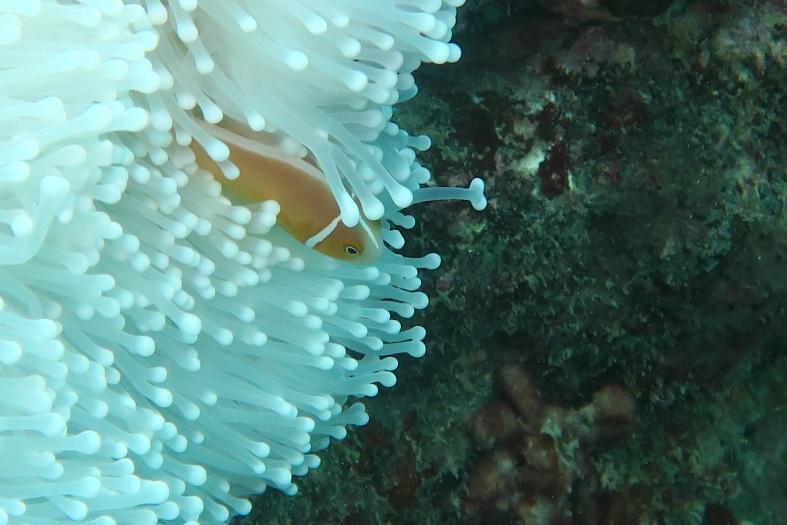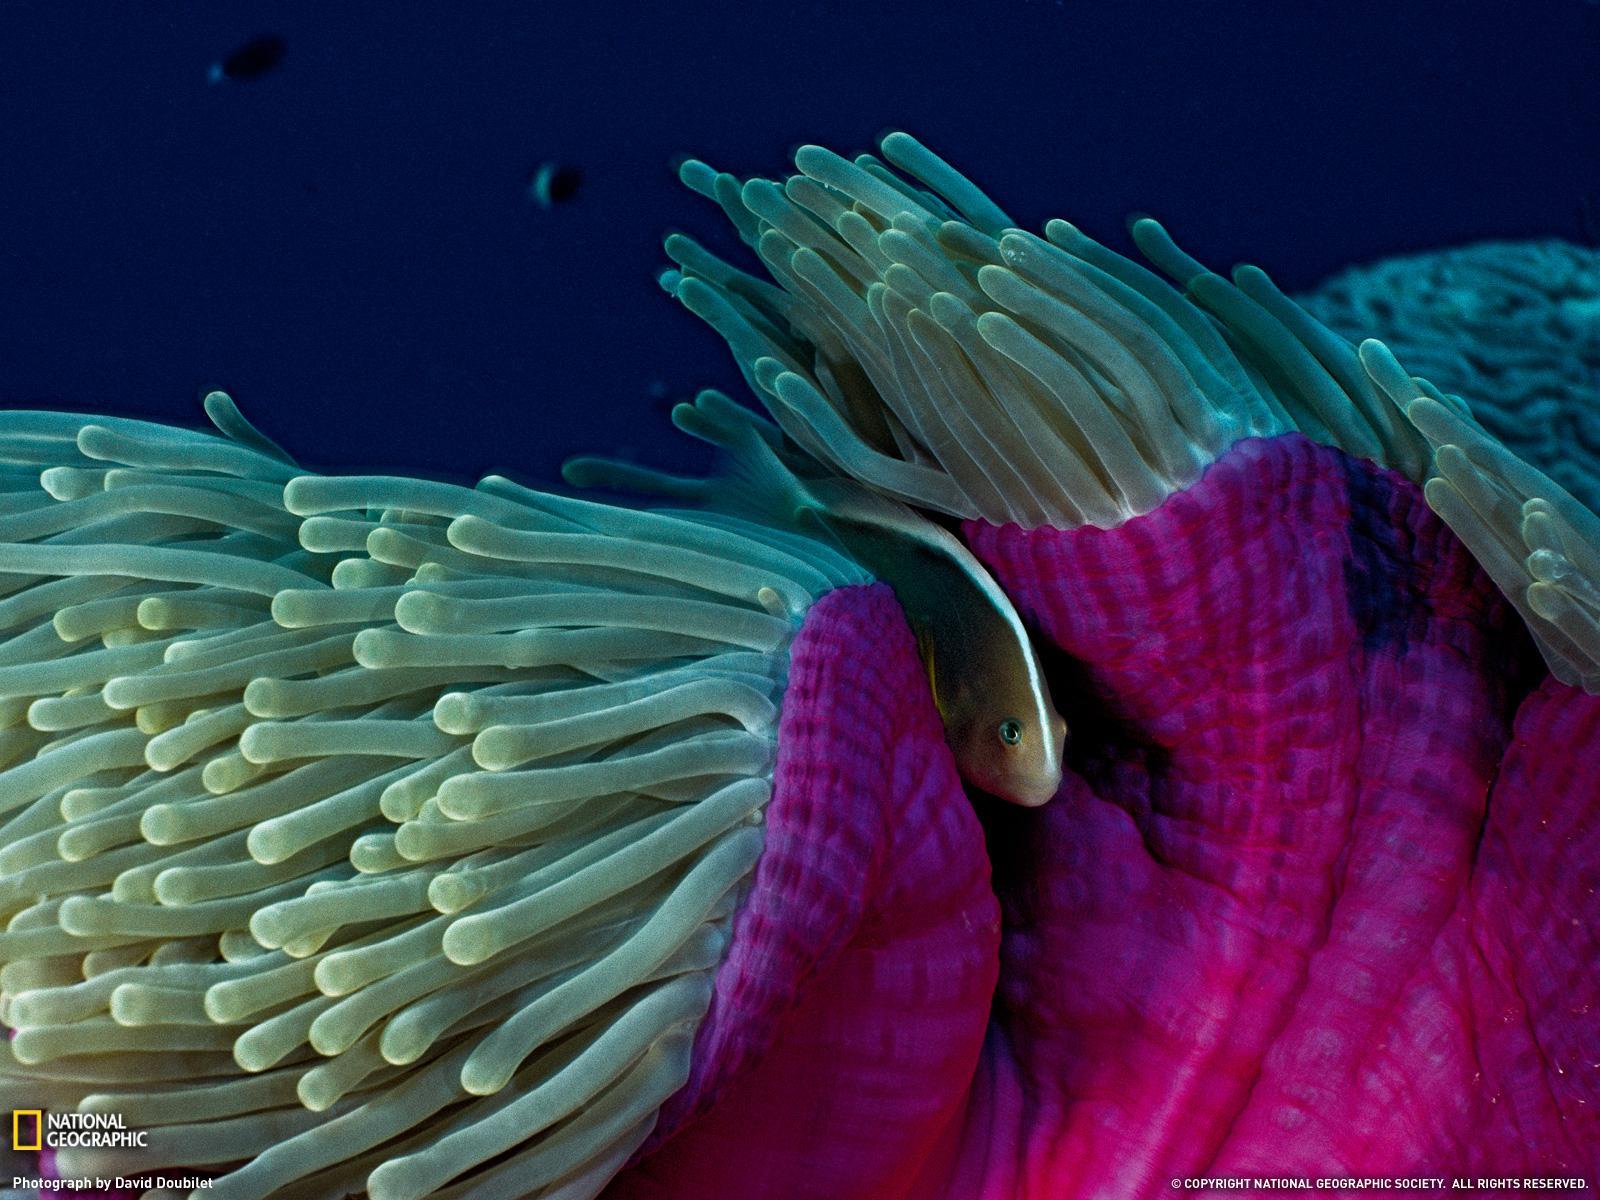The first image is the image on the left, the second image is the image on the right. Assess this claim about the two images: "The left image contains a single fish.". Correct or not? Answer yes or no. Yes. The first image is the image on the left, the second image is the image on the right. Analyze the images presented: Is the assertion "In at least one image there is a hot pink collar with an orange and pink fish swimming on top of it." valid? Answer yes or no. No. 